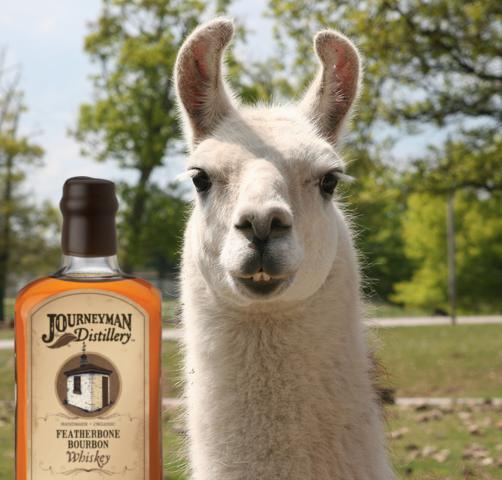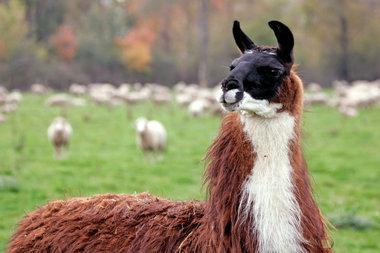The first image is the image on the left, the second image is the image on the right. Assess this claim about the two images: "Two llamas are wearing bow ties and little hats.". Correct or not? Answer yes or no. No. 